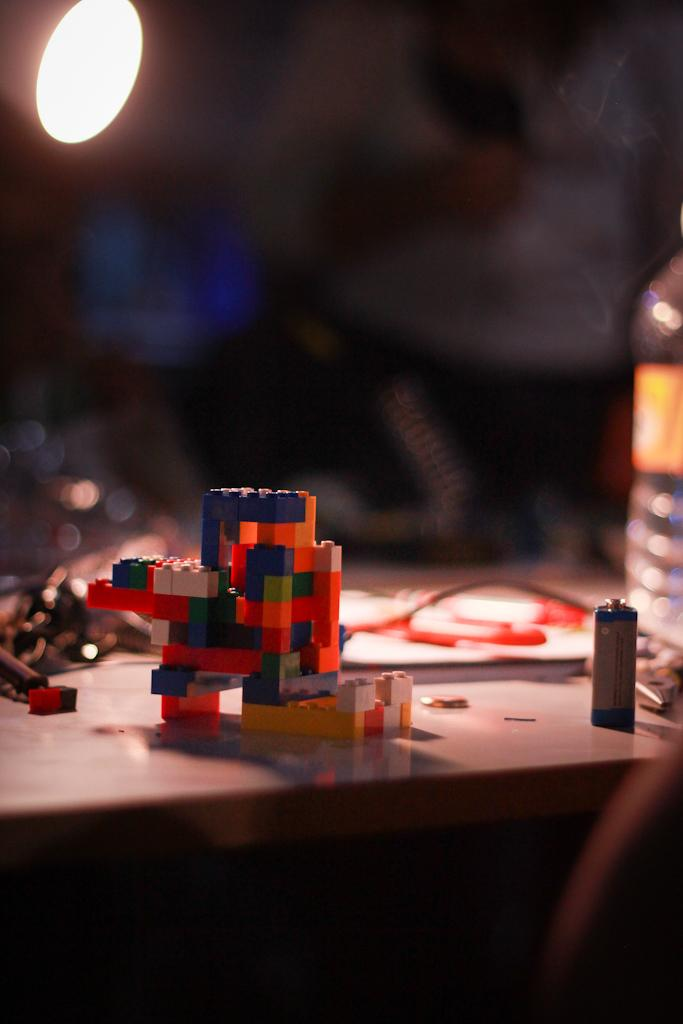What type of toy is in the image? There is a Lego toy in the image. What else can be seen in the image besides the toy? There is water visible in the image, and there are other objects on the table. Where is the light located in the image? The light is on the left side of the image. How would you describe the background of the image? The background of the image is blurred. What type of dress is hanging on the sofa in the image? There is no sofa or dress present in the image. How does the snow affect the visibility of the Lego toy in the image? There is no snow present in the image, so it does not affect the visibility of the Lego toy. 